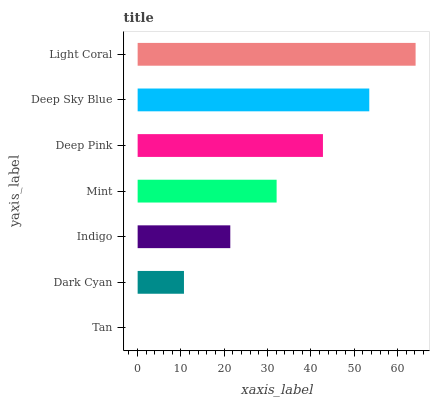Is Tan the minimum?
Answer yes or no. Yes. Is Light Coral the maximum?
Answer yes or no. Yes. Is Dark Cyan the minimum?
Answer yes or no. No. Is Dark Cyan the maximum?
Answer yes or no. No. Is Dark Cyan greater than Tan?
Answer yes or no. Yes. Is Tan less than Dark Cyan?
Answer yes or no. Yes. Is Tan greater than Dark Cyan?
Answer yes or no. No. Is Dark Cyan less than Tan?
Answer yes or no. No. Is Mint the high median?
Answer yes or no. Yes. Is Mint the low median?
Answer yes or no. Yes. Is Deep Sky Blue the high median?
Answer yes or no. No. Is Dark Cyan the low median?
Answer yes or no. No. 